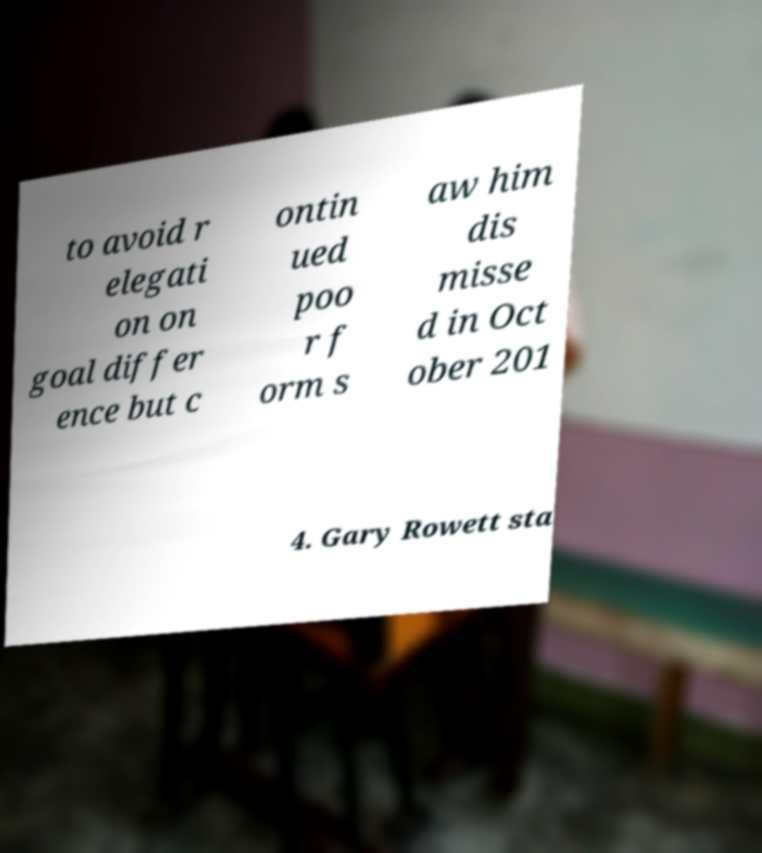Could you assist in decoding the text presented in this image and type it out clearly? to avoid r elegati on on goal differ ence but c ontin ued poo r f orm s aw him dis misse d in Oct ober 201 4. Gary Rowett sta 